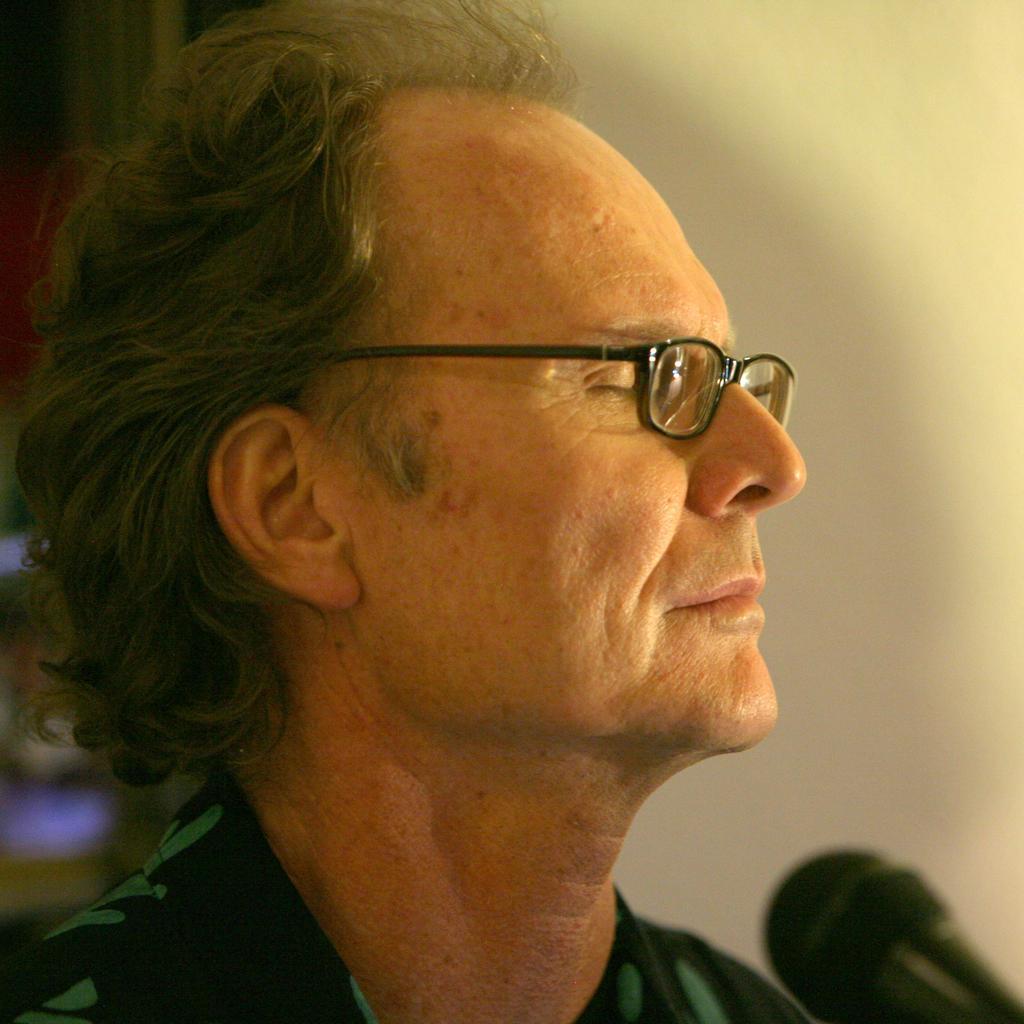Please provide a concise description of this image. In this picture we can see a man wore a spectacle and in front of him we can see a mic and in the background we can see the wall and some objects. 